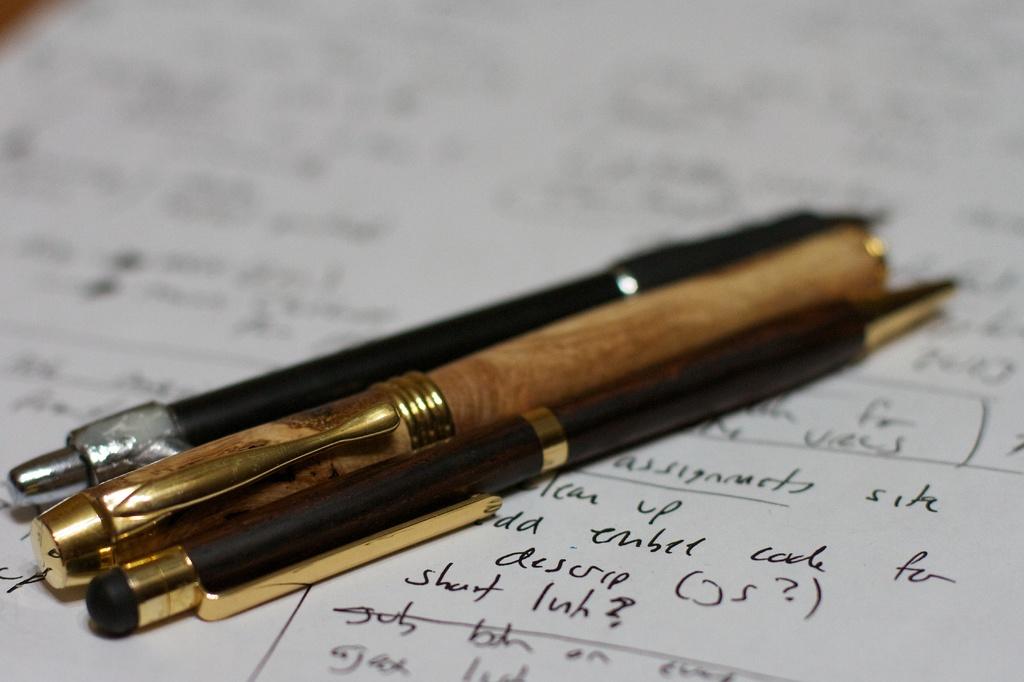Are all these pens black ink?
Give a very brief answer. Answering does not require reading text in the image. 